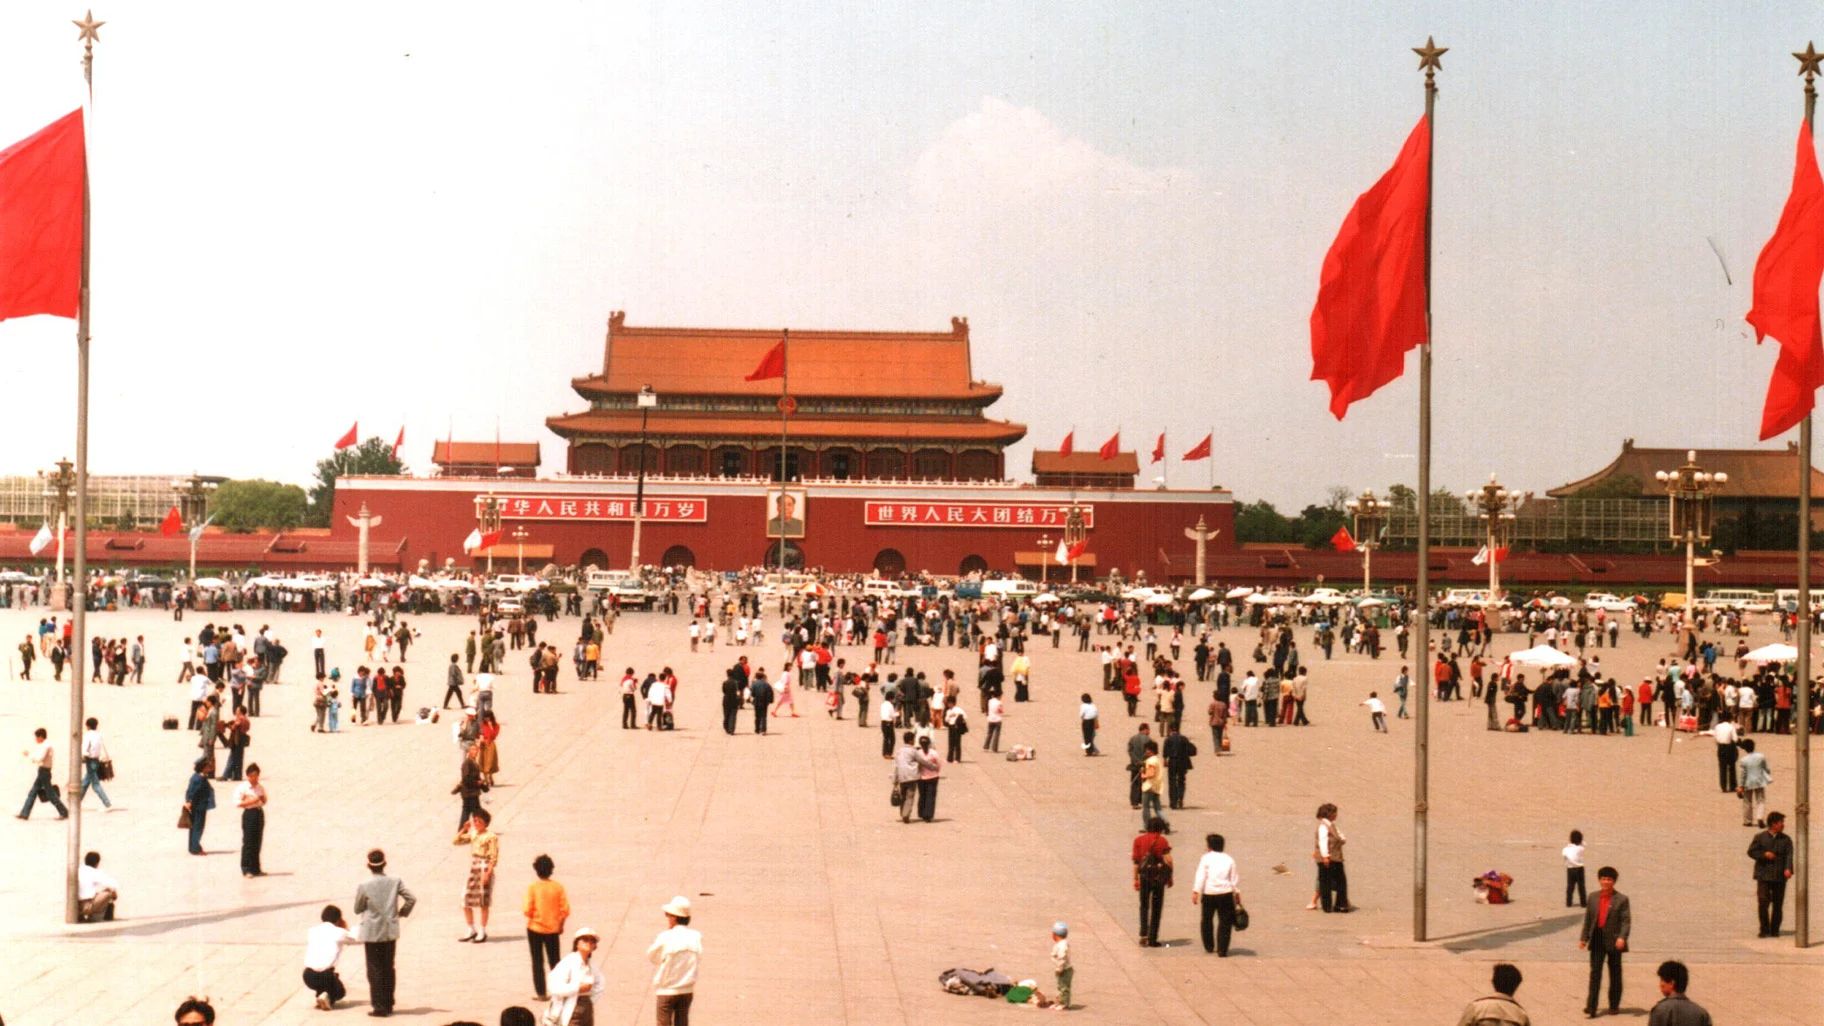Imagine the square transforms into a gigantic chessboard for a world championship game. Describe the scene. In an astonishing transformation, Tiananmen Square has become the grand stage for the World Chess Championship. Giant chess pieces, each half the height of a person, are meticulously positioned on a colossal checkerboard painted on the square's surface. Spectators from around the globe gather, their eyes wide with amazement, as grandmasters in elaborate traditional and modern attire take strategic strides across the board. The vivid red flags fluttering in the breeze add a dynamic touch to the scene, harmonizing with the vibrant energy of chess enthusiasts and curious onlookers alike. The historic Tiananmen building, now adorned with oversized chess banners, stands proudly in the backdrop, presiding over this unprecedented convergence of culture, intellect, and history. 